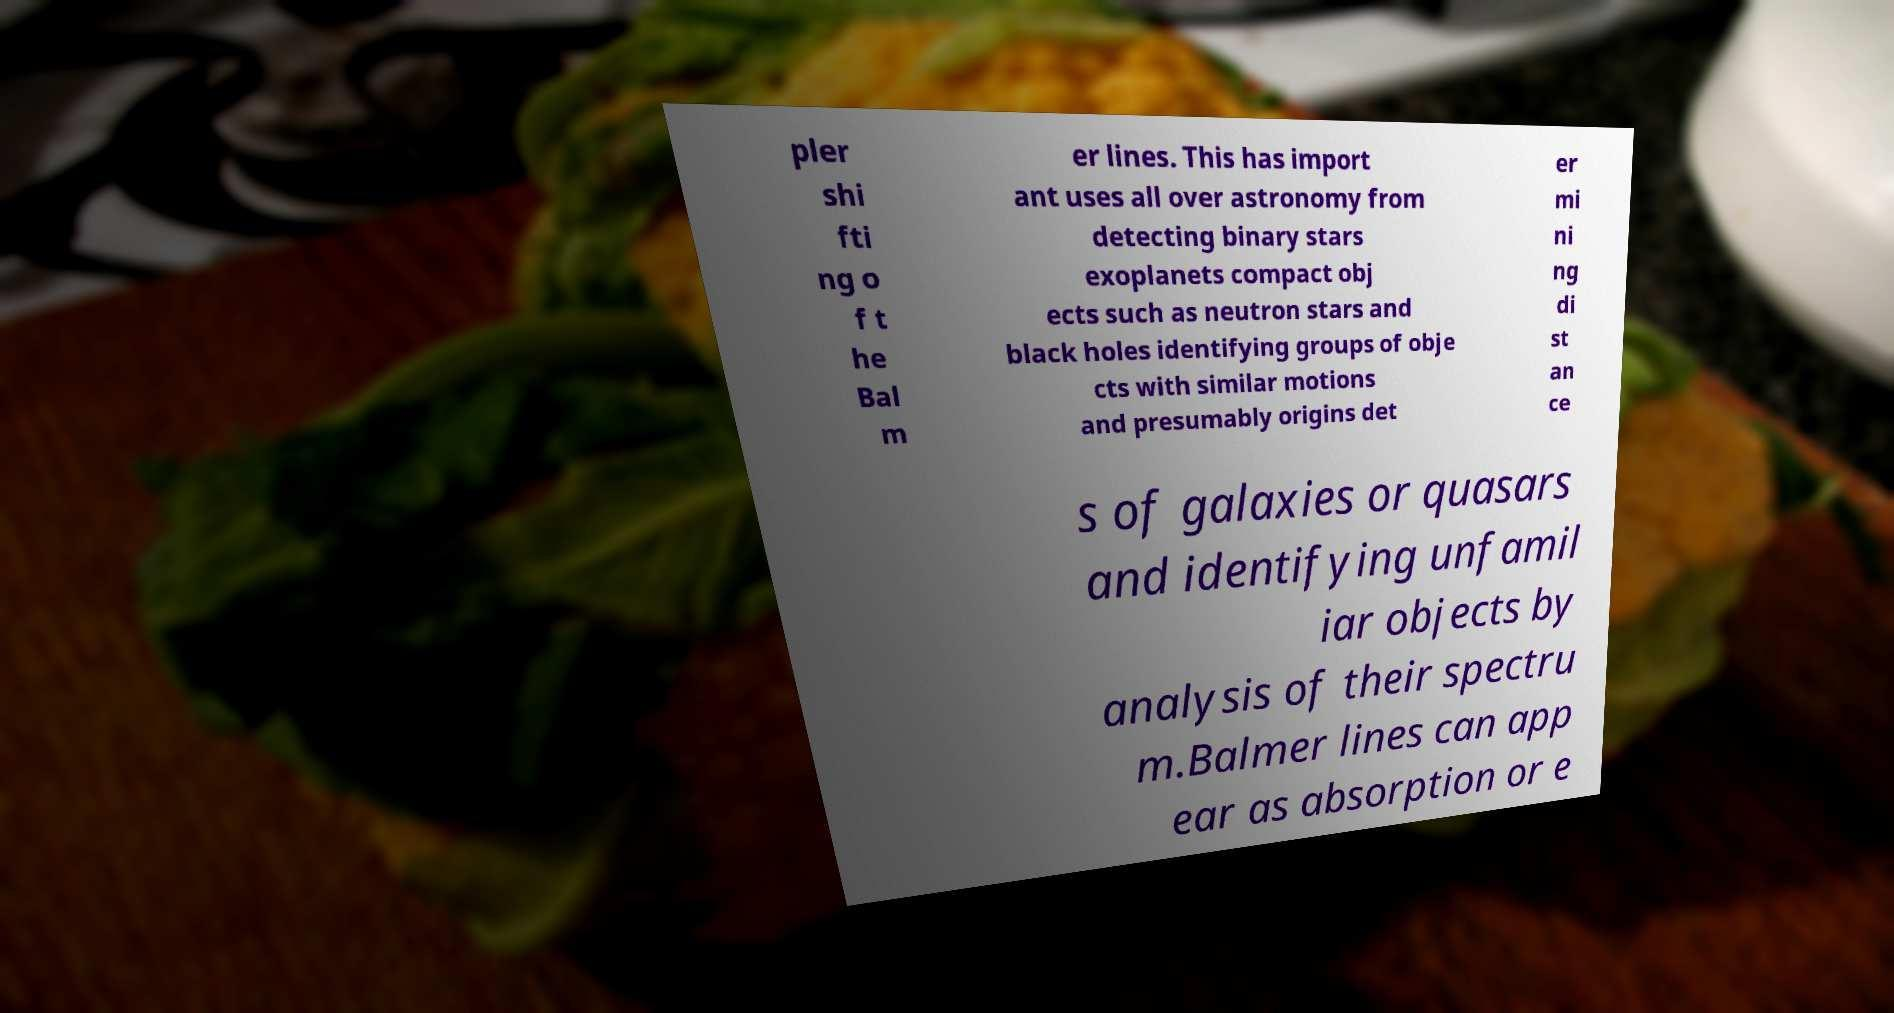Could you assist in decoding the text presented in this image and type it out clearly? pler shi fti ng o f t he Bal m er lines. This has import ant uses all over astronomy from detecting binary stars exoplanets compact obj ects such as neutron stars and black holes identifying groups of obje cts with similar motions and presumably origins det er mi ni ng di st an ce s of galaxies or quasars and identifying unfamil iar objects by analysis of their spectru m.Balmer lines can app ear as absorption or e 